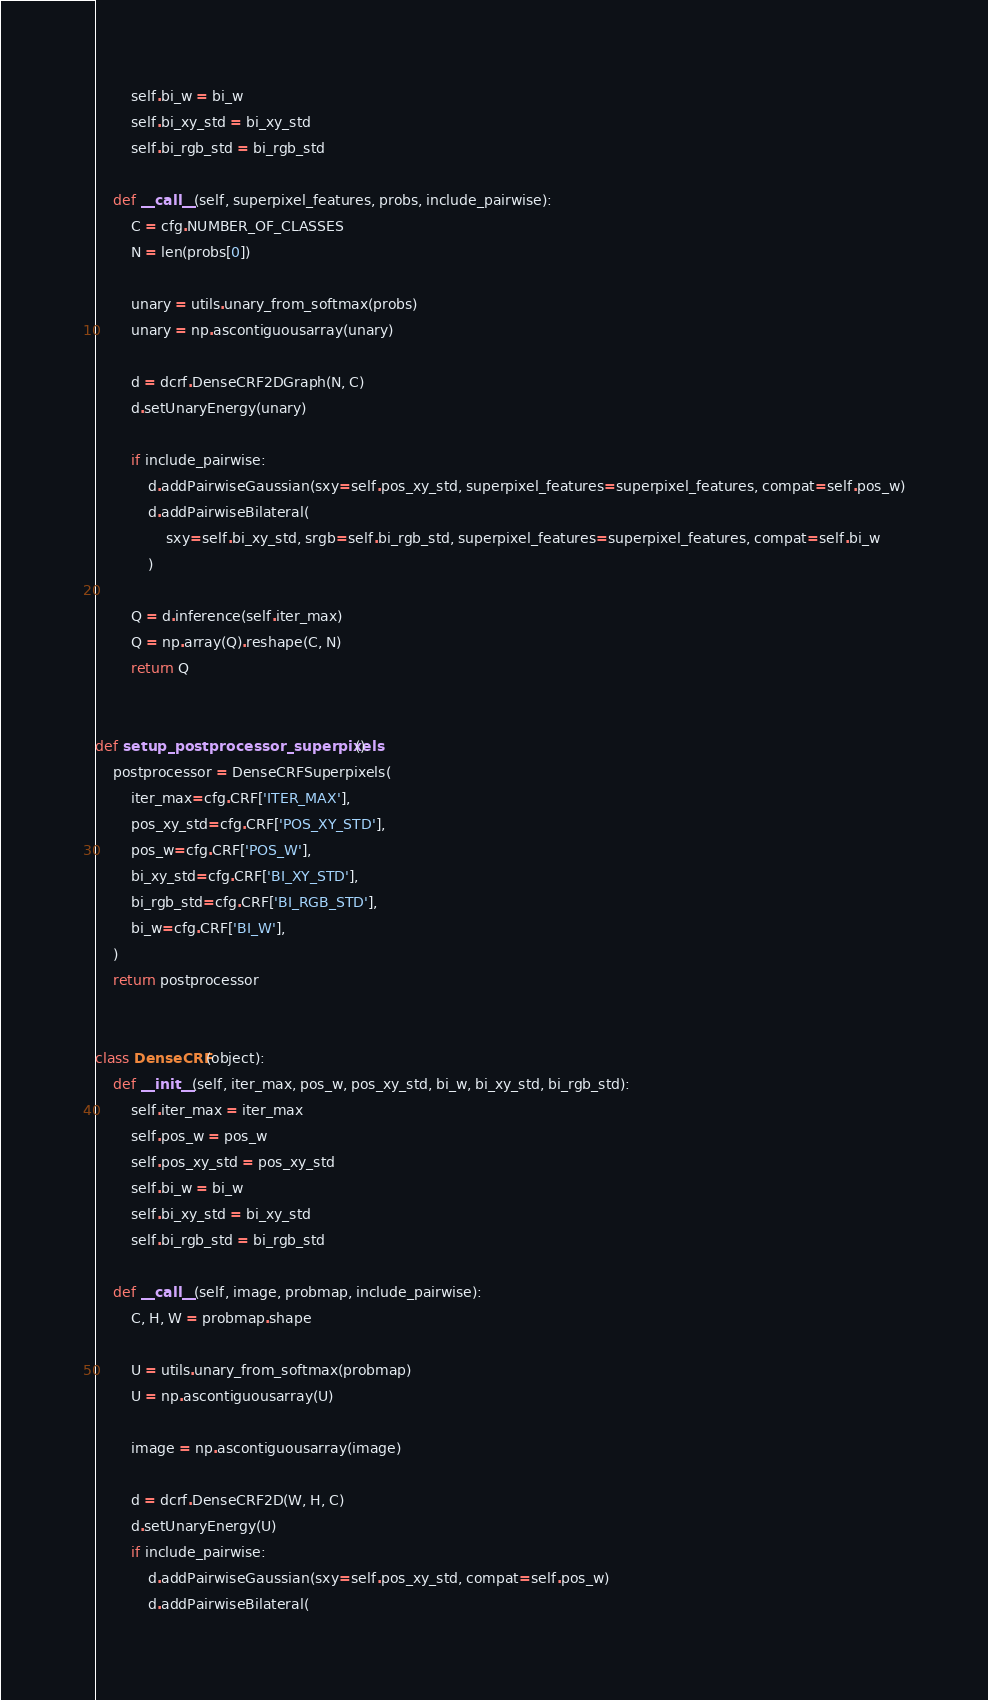Convert code to text. <code><loc_0><loc_0><loc_500><loc_500><_Python_>        self.bi_w = bi_w
        self.bi_xy_std = bi_xy_std
        self.bi_rgb_std = bi_rgb_std

    def __call__(self, superpixel_features, probs, include_pairwise):
        C = cfg.NUMBER_OF_CLASSES
        N = len(probs[0])

        unary = utils.unary_from_softmax(probs)
        unary = np.ascontiguousarray(unary)

        d = dcrf.DenseCRF2DGraph(N, C)
        d.setUnaryEnergy(unary)

        if include_pairwise:
            d.addPairwiseGaussian(sxy=self.pos_xy_std, superpixel_features=superpixel_features, compat=self.pos_w)
            d.addPairwiseBilateral(
                sxy=self.bi_xy_std, srgb=self.bi_rgb_std, superpixel_features=superpixel_features, compat=self.bi_w
            )

        Q = d.inference(self.iter_max)
        Q = np.array(Q).reshape(C, N)
        return Q


def setup_postprocessor_superpixels():
    postprocessor = DenseCRFSuperpixels(
        iter_max=cfg.CRF['ITER_MAX'],
        pos_xy_std=cfg.CRF['POS_XY_STD'],
        pos_w=cfg.CRF['POS_W'],
        bi_xy_std=cfg.CRF['BI_XY_STD'],
        bi_rgb_std=cfg.CRF['BI_RGB_STD'],
        bi_w=cfg.CRF['BI_W'],
    )
    return postprocessor


class DenseCRF(object):
    def __init__(self, iter_max, pos_w, pos_xy_std, bi_w, bi_xy_std, bi_rgb_std):
        self.iter_max = iter_max
        self.pos_w = pos_w
        self.pos_xy_std = pos_xy_std
        self.bi_w = bi_w
        self.bi_xy_std = bi_xy_std
        self.bi_rgb_std = bi_rgb_std

    def __call__(self, image, probmap, include_pairwise):
        C, H, W = probmap.shape

        U = utils.unary_from_softmax(probmap)
        U = np.ascontiguousarray(U)

        image = np.ascontiguousarray(image)

        d = dcrf.DenseCRF2D(W, H, C)
        d.setUnaryEnergy(U)
        if include_pairwise:
            d.addPairwiseGaussian(sxy=self.pos_xy_std, compat=self.pos_w)
            d.addPairwiseBilateral(</code> 